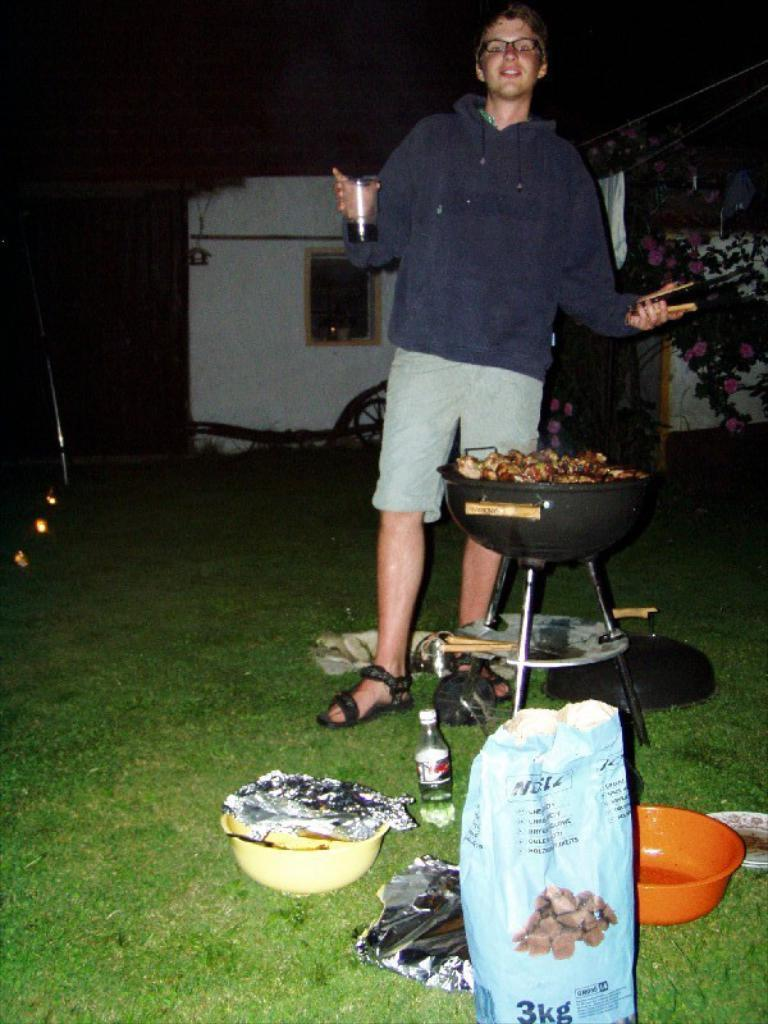<image>
Offer a succinct explanation of the picture presented. A man is standing at a grill with a 3kg bag near him. 